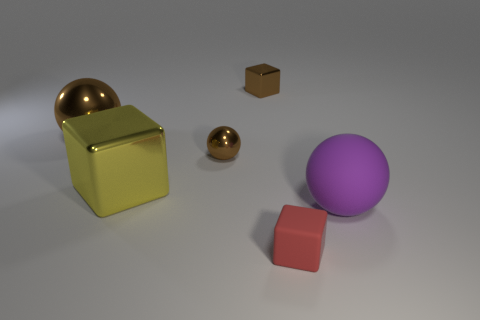There is a large sphere behind the large sphere on the right side of the tiny thing in front of the purple matte sphere; what is its color?
Your response must be concise. Brown. Are the yellow object and the big ball that is left of the purple rubber ball made of the same material?
Give a very brief answer. Yes. What is the tiny red thing made of?
Make the answer very short. Rubber. There is a small ball that is the same color as the tiny metal block; what material is it?
Offer a very short reply. Metal. What number of other things are there of the same material as the small red block
Your answer should be very brief. 1. What shape is the small object that is in front of the big brown object and behind the purple sphere?
Keep it short and to the point. Sphere. What is the color of the sphere that is made of the same material as the tiny red block?
Keep it short and to the point. Purple. Are there the same number of big yellow cubes that are behind the purple thing and small rubber cubes?
Make the answer very short. Yes. There is a brown shiny thing that is the same size as the purple rubber sphere; what shape is it?
Give a very brief answer. Sphere. What number of other things are the same shape as the big purple object?
Provide a short and direct response. 2. 